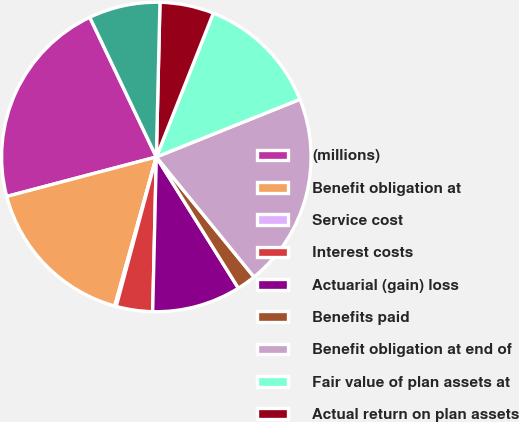Convert chart. <chart><loc_0><loc_0><loc_500><loc_500><pie_chart><fcel>(millions)<fcel>Benefit obligation at<fcel>Service cost<fcel>Interest costs<fcel>Actuarial (gain) loss<fcel>Benefits paid<fcel>Benefit obligation at end of<fcel>Fair value of plan assets at<fcel>Actual return on plan assets<fcel>Employer contributions<nl><fcel>22.03%<fcel>16.56%<fcel>0.16%<fcel>3.8%<fcel>9.27%<fcel>1.98%<fcel>20.2%<fcel>12.92%<fcel>5.63%<fcel>7.45%<nl></chart> 